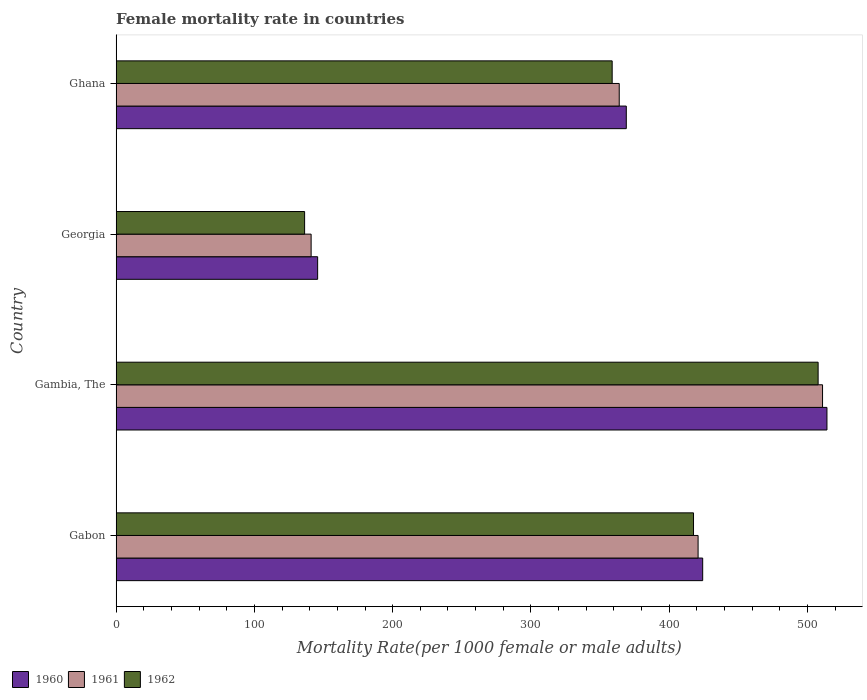How many groups of bars are there?
Give a very brief answer. 4. Are the number of bars per tick equal to the number of legend labels?
Your answer should be very brief. Yes. What is the female mortality rate in 1960 in Georgia?
Give a very brief answer. 145.74. Across all countries, what is the maximum female mortality rate in 1960?
Give a very brief answer. 514.09. Across all countries, what is the minimum female mortality rate in 1962?
Provide a short and direct response. 136.31. In which country was the female mortality rate in 1961 maximum?
Your answer should be very brief. Gambia, The. In which country was the female mortality rate in 1962 minimum?
Ensure brevity in your answer.  Georgia. What is the total female mortality rate in 1962 in the graph?
Offer a terse response. 1420.37. What is the difference between the female mortality rate in 1960 in Gabon and that in Gambia, The?
Your answer should be compact. -89.88. What is the difference between the female mortality rate in 1962 in Gambia, The and the female mortality rate in 1960 in Ghana?
Make the answer very short. 138.73. What is the average female mortality rate in 1960 per country?
Your response must be concise. 363.26. What is the difference between the female mortality rate in 1960 and female mortality rate in 1962 in Gambia, The?
Your answer should be compact. 6.38. In how many countries, is the female mortality rate in 1961 greater than 200 ?
Your response must be concise. 3. What is the ratio of the female mortality rate in 1961 in Gabon to that in Gambia, The?
Ensure brevity in your answer.  0.82. Is the female mortality rate in 1960 in Gabon less than that in Georgia?
Your response must be concise. No. Is the difference between the female mortality rate in 1960 in Georgia and Ghana greater than the difference between the female mortality rate in 1962 in Georgia and Ghana?
Keep it short and to the point. No. What is the difference between the highest and the second highest female mortality rate in 1962?
Your answer should be compact. 90.13. What is the difference between the highest and the lowest female mortality rate in 1962?
Give a very brief answer. 371.4. Are all the bars in the graph horizontal?
Your answer should be very brief. Yes. What is the difference between two consecutive major ticks on the X-axis?
Your answer should be compact. 100. Are the values on the major ticks of X-axis written in scientific E-notation?
Offer a very short reply. No. Where does the legend appear in the graph?
Your response must be concise. Bottom left. How many legend labels are there?
Your answer should be very brief. 3. What is the title of the graph?
Offer a terse response. Female mortality rate in countries. What is the label or title of the X-axis?
Provide a succinct answer. Mortality Rate(per 1000 female or male adults). What is the label or title of the Y-axis?
Provide a short and direct response. Country. What is the Mortality Rate(per 1000 female or male adults) of 1960 in Gabon?
Your answer should be very brief. 424.22. What is the Mortality Rate(per 1000 female or male adults) of 1961 in Gabon?
Ensure brevity in your answer.  420.9. What is the Mortality Rate(per 1000 female or male adults) of 1962 in Gabon?
Give a very brief answer. 417.59. What is the Mortality Rate(per 1000 female or male adults) in 1960 in Gambia, The?
Your response must be concise. 514.09. What is the Mortality Rate(per 1000 female or male adults) in 1961 in Gambia, The?
Give a very brief answer. 510.9. What is the Mortality Rate(per 1000 female or male adults) of 1962 in Gambia, The?
Ensure brevity in your answer.  507.71. What is the Mortality Rate(per 1000 female or male adults) in 1960 in Georgia?
Provide a succinct answer. 145.74. What is the Mortality Rate(per 1000 female or male adults) in 1961 in Georgia?
Keep it short and to the point. 141.03. What is the Mortality Rate(per 1000 female or male adults) of 1962 in Georgia?
Provide a short and direct response. 136.31. What is the Mortality Rate(per 1000 female or male adults) of 1960 in Ghana?
Provide a short and direct response. 368.98. What is the Mortality Rate(per 1000 female or male adults) in 1961 in Ghana?
Your response must be concise. 363.87. What is the Mortality Rate(per 1000 female or male adults) of 1962 in Ghana?
Your answer should be very brief. 358.76. Across all countries, what is the maximum Mortality Rate(per 1000 female or male adults) of 1960?
Ensure brevity in your answer.  514.09. Across all countries, what is the maximum Mortality Rate(per 1000 female or male adults) of 1961?
Your answer should be compact. 510.9. Across all countries, what is the maximum Mortality Rate(per 1000 female or male adults) of 1962?
Give a very brief answer. 507.71. Across all countries, what is the minimum Mortality Rate(per 1000 female or male adults) of 1960?
Your response must be concise. 145.74. Across all countries, what is the minimum Mortality Rate(per 1000 female or male adults) in 1961?
Your answer should be compact. 141.03. Across all countries, what is the minimum Mortality Rate(per 1000 female or male adults) in 1962?
Make the answer very short. 136.31. What is the total Mortality Rate(per 1000 female or male adults) in 1960 in the graph?
Provide a short and direct response. 1453.03. What is the total Mortality Rate(per 1000 female or male adults) in 1961 in the graph?
Offer a terse response. 1436.7. What is the total Mortality Rate(per 1000 female or male adults) in 1962 in the graph?
Keep it short and to the point. 1420.37. What is the difference between the Mortality Rate(per 1000 female or male adults) of 1960 in Gabon and that in Gambia, The?
Your answer should be very brief. -89.88. What is the difference between the Mortality Rate(per 1000 female or male adults) of 1961 in Gabon and that in Gambia, The?
Your response must be concise. -90. What is the difference between the Mortality Rate(per 1000 female or male adults) in 1962 in Gabon and that in Gambia, The?
Make the answer very short. -90.13. What is the difference between the Mortality Rate(per 1000 female or male adults) in 1960 in Gabon and that in Georgia?
Give a very brief answer. 278.48. What is the difference between the Mortality Rate(per 1000 female or male adults) of 1961 in Gabon and that in Georgia?
Your answer should be very brief. 279.87. What is the difference between the Mortality Rate(per 1000 female or male adults) of 1962 in Gabon and that in Georgia?
Ensure brevity in your answer.  281.27. What is the difference between the Mortality Rate(per 1000 female or male adults) of 1960 in Gabon and that in Ghana?
Your answer should be compact. 55.24. What is the difference between the Mortality Rate(per 1000 female or male adults) of 1961 in Gabon and that in Ghana?
Provide a succinct answer. 57.03. What is the difference between the Mortality Rate(per 1000 female or male adults) of 1962 in Gabon and that in Ghana?
Provide a short and direct response. 58.83. What is the difference between the Mortality Rate(per 1000 female or male adults) of 1960 in Gambia, The and that in Georgia?
Ensure brevity in your answer.  368.35. What is the difference between the Mortality Rate(per 1000 female or male adults) in 1961 in Gambia, The and that in Georgia?
Offer a terse response. 369.88. What is the difference between the Mortality Rate(per 1000 female or male adults) in 1962 in Gambia, The and that in Georgia?
Give a very brief answer. 371.4. What is the difference between the Mortality Rate(per 1000 female or male adults) in 1960 in Gambia, The and that in Ghana?
Ensure brevity in your answer.  145.12. What is the difference between the Mortality Rate(per 1000 female or male adults) in 1961 in Gambia, The and that in Ghana?
Provide a succinct answer. 147.03. What is the difference between the Mortality Rate(per 1000 female or male adults) of 1962 in Gambia, The and that in Ghana?
Keep it short and to the point. 148.96. What is the difference between the Mortality Rate(per 1000 female or male adults) of 1960 in Georgia and that in Ghana?
Provide a short and direct response. -223.24. What is the difference between the Mortality Rate(per 1000 female or male adults) in 1961 in Georgia and that in Ghana?
Your response must be concise. -222.84. What is the difference between the Mortality Rate(per 1000 female or male adults) of 1962 in Georgia and that in Ghana?
Make the answer very short. -222.44. What is the difference between the Mortality Rate(per 1000 female or male adults) in 1960 in Gabon and the Mortality Rate(per 1000 female or male adults) in 1961 in Gambia, The?
Provide a short and direct response. -86.69. What is the difference between the Mortality Rate(per 1000 female or male adults) of 1960 in Gabon and the Mortality Rate(per 1000 female or male adults) of 1962 in Gambia, The?
Give a very brief answer. -83.5. What is the difference between the Mortality Rate(per 1000 female or male adults) of 1961 in Gabon and the Mortality Rate(per 1000 female or male adults) of 1962 in Gambia, The?
Your response must be concise. -86.81. What is the difference between the Mortality Rate(per 1000 female or male adults) in 1960 in Gabon and the Mortality Rate(per 1000 female or male adults) in 1961 in Georgia?
Your answer should be very brief. 283.19. What is the difference between the Mortality Rate(per 1000 female or male adults) of 1960 in Gabon and the Mortality Rate(per 1000 female or male adults) of 1962 in Georgia?
Your answer should be compact. 287.9. What is the difference between the Mortality Rate(per 1000 female or male adults) of 1961 in Gabon and the Mortality Rate(per 1000 female or male adults) of 1962 in Georgia?
Your answer should be compact. 284.59. What is the difference between the Mortality Rate(per 1000 female or male adults) in 1960 in Gabon and the Mortality Rate(per 1000 female or male adults) in 1961 in Ghana?
Your answer should be very brief. 60.35. What is the difference between the Mortality Rate(per 1000 female or male adults) of 1960 in Gabon and the Mortality Rate(per 1000 female or male adults) of 1962 in Ghana?
Your response must be concise. 65.46. What is the difference between the Mortality Rate(per 1000 female or male adults) in 1961 in Gabon and the Mortality Rate(per 1000 female or male adults) in 1962 in Ghana?
Give a very brief answer. 62.14. What is the difference between the Mortality Rate(per 1000 female or male adults) in 1960 in Gambia, The and the Mortality Rate(per 1000 female or male adults) in 1961 in Georgia?
Ensure brevity in your answer.  373.07. What is the difference between the Mortality Rate(per 1000 female or male adults) of 1960 in Gambia, The and the Mortality Rate(per 1000 female or male adults) of 1962 in Georgia?
Keep it short and to the point. 377.78. What is the difference between the Mortality Rate(per 1000 female or male adults) of 1961 in Gambia, The and the Mortality Rate(per 1000 female or male adults) of 1962 in Georgia?
Offer a very short reply. 374.59. What is the difference between the Mortality Rate(per 1000 female or male adults) of 1960 in Gambia, The and the Mortality Rate(per 1000 female or male adults) of 1961 in Ghana?
Keep it short and to the point. 150.23. What is the difference between the Mortality Rate(per 1000 female or male adults) of 1960 in Gambia, The and the Mortality Rate(per 1000 female or male adults) of 1962 in Ghana?
Make the answer very short. 155.34. What is the difference between the Mortality Rate(per 1000 female or male adults) of 1961 in Gambia, The and the Mortality Rate(per 1000 female or male adults) of 1962 in Ghana?
Keep it short and to the point. 152.15. What is the difference between the Mortality Rate(per 1000 female or male adults) in 1960 in Georgia and the Mortality Rate(per 1000 female or male adults) in 1961 in Ghana?
Give a very brief answer. -218.13. What is the difference between the Mortality Rate(per 1000 female or male adults) in 1960 in Georgia and the Mortality Rate(per 1000 female or male adults) in 1962 in Ghana?
Give a very brief answer. -213.02. What is the difference between the Mortality Rate(per 1000 female or male adults) of 1961 in Georgia and the Mortality Rate(per 1000 female or male adults) of 1962 in Ghana?
Keep it short and to the point. -217.73. What is the average Mortality Rate(per 1000 female or male adults) in 1960 per country?
Provide a short and direct response. 363.26. What is the average Mortality Rate(per 1000 female or male adults) in 1961 per country?
Make the answer very short. 359.17. What is the average Mortality Rate(per 1000 female or male adults) in 1962 per country?
Your response must be concise. 355.09. What is the difference between the Mortality Rate(per 1000 female or male adults) in 1960 and Mortality Rate(per 1000 female or male adults) in 1961 in Gabon?
Provide a short and direct response. 3.31. What is the difference between the Mortality Rate(per 1000 female or male adults) in 1960 and Mortality Rate(per 1000 female or male adults) in 1962 in Gabon?
Keep it short and to the point. 6.63. What is the difference between the Mortality Rate(per 1000 female or male adults) of 1961 and Mortality Rate(per 1000 female or male adults) of 1962 in Gabon?
Make the answer very short. 3.31. What is the difference between the Mortality Rate(per 1000 female or male adults) in 1960 and Mortality Rate(per 1000 female or male adults) in 1961 in Gambia, The?
Offer a terse response. 3.19. What is the difference between the Mortality Rate(per 1000 female or male adults) in 1960 and Mortality Rate(per 1000 female or male adults) in 1962 in Gambia, The?
Your response must be concise. 6.38. What is the difference between the Mortality Rate(per 1000 female or male adults) in 1961 and Mortality Rate(per 1000 female or male adults) in 1962 in Gambia, The?
Keep it short and to the point. 3.19. What is the difference between the Mortality Rate(per 1000 female or male adults) of 1960 and Mortality Rate(per 1000 female or male adults) of 1961 in Georgia?
Offer a terse response. 4.71. What is the difference between the Mortality Rate(per 1000 female or male adults) in 1960 and Mortality Rate(per 1000 female or male adults) in 1962 in Georgia?
Your response must be concise. 9.43. What is the difference between the Mortality Rate(per 1000 female or male adults) in 1961 and Mortality Rate(per 1000 female or male adults) in 1962 in Georgia?
Make the answer very short. 4.71. What is the difference between the Mortality Rate(per 1000 female or male adults) of 1960 and Mortality Rate(per 1000 female or male adults) of 1961 in Ghana?
Provide a short and direct response. 5.11. What is the difference between the Mortality Rate(per 1000 female or male adults) in 1960 and Mortality Rate(per 1000 female or male adults) in 1962 in Ghana?
Ensure brevity in your answer.  10.22. What is the difference between the Mortality Rate(per 1000 female or male adults) in 1961 and Mortality Rate(per 1000 female or male adults) in 1962 in Ghana?
Provide a succinct answer. 5.11. What is the ratio of the Mortality Rate(per 1000 female or male adults) of 1960 in Gabon to that in Gambia, The?
Provide a short and direct response. 0.83. What is the ratio of the Mortality Rate(per 1000 female or male adults) in 1961 in Gabon to that in Gambia, The?
Provide a short and direct response. 0.82. What is the ratio of the Mortality Rate(per 1000 female or male adults) of 1962 in Gabon to that in Gambia, The?
Offer a very short reply. 0.82. What is the ratio of the Mortality Rate(per 1000 female or male adults) in 1960 in Gabon to that in Georgia?
Provide a short and direct response. 2.91. What is the ratio of the Mortality Rate(per 1000 female or male adults) in 1961 in Gabon to that in Georgia?
Your response must be concise. 2.98. What is the ratio of the Mortality Rate(per 1000 female or male adults) in 1962 in Gabon to that in Georgia?
Your response must be concise. 3.06. What is the ratio of the Mortality Rate(per 1000 female or male adults) in 1960 in Gabon to that in Ghana?
Provide a short and direct response. 1.15. What is the ratio of the Mortality Rate(per 1000 female or male adults) in 1961 in Gabon to that in Ghana?
Make the answer very short. 1.16. What is the ratio of the Mortality Rate(per 1000 female or male adults) of 1962 in Gabon to that in Ghana?
Your response must be concise. 1.16. What is the ratio of the Mortality Rate(per 1000 female or male adults) of 1960 in Gambia, The to that in Georgia?
Keep it short and to the point. 3.53. What is the ratio of the Mortality Rate(per 1000 female or male adults) in 1961 in Gambia, The to that in Georgia?
Make the answer very short. 3.62. What is the ratio of the Mortality Rate(per 1000 female or male adults) in 1962 in Gambia, The to that in Georgia?
Your answer should be compact. 3.72. What is the ratio of the Mortality Rate(per 1000 female or male adults) in 1960 in Gambia, The to that in Ghana?
Offer a terse response. 1.39. What is the ratio of the Mortality Rate(per 1000 female or male adults) in 1961 in Gambia, The to that in Ghana?
Ensure brevity in your answer.  1.4. What is the ratio of the Mortality Rate(per 1000 female or male adults) of 1962 in Gambia, The to that in Ghana?
Your answer should be compact. 1.42. What is the ratio of the Mortality Rate(per 1000 female or male adults) of 1960 in Georgia to that in Ghana?
Your response must be concise. 0.4. What is the ratio of the Mortality Rate(per 1000 female or male adults) of 1961 in Georgia to that in Ghana?
Provide a short and direct response. 0.39. What is the ratio of the Mortality Rate(per 1000 female or male adults) of 1962 in Georgia to that in Ghana?
Keep it short and to the point. 0.38. What is the difference between the highest and the second highest Mortality Rate(per 1000 female or male adults) in 1960?
Your answer should be compact. 89.88. What is the difference between the highest and the second highest Mortality Rate(per 1000 female or male adults) in 1961?
Make the answer very short. 90. What is the difference between the highest and the second highest Mortality Rate(per 1000 female or male adults) in 1962?
Make the answer very short. 90.13. What is the difference between the highest and the lowest Mortality Rate(per 1000 female or male adults) in 1960?
Offer a very short reply. 368.35. What is the difference between the highest and the lowest Mortality Rate(per 1000 female or male adults) of 1961?
Your response must be concise. 369.88. What is the difference between the highest and the lowest Mortality Rate(per 1000 female or male adults) of 1962?
Ensure brevity in your answer.  371.4. 